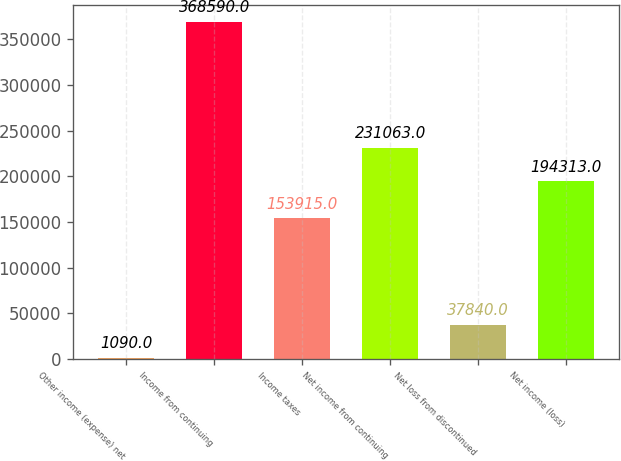Convert chart to OTSL. <chart><loc_0><loc_0><loc_500><loc_500><bar_chart><fcel>Other income (expense) net<fcel>Income from continuing<fcel>Income taxes<fcel>Net income from continuing<fcel>Net loss from discontinued<fcel>Net income (loss)<nl><fcel>1090<fcel>368590<fcel>153915<fcel>231063<fcel>37840<fcel>194313<nl></chart> 